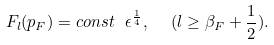<formula> <loc_0><loc_0><loc_500><loc_500>F _ { l } ( p _ { F } ) = c o n s t \ \epsilon ^ { \frac { 1 } { 4 } } , \ \ ( l \geq \beta _ { F } + \frac { 1 } { 2 } ) .</formula> 